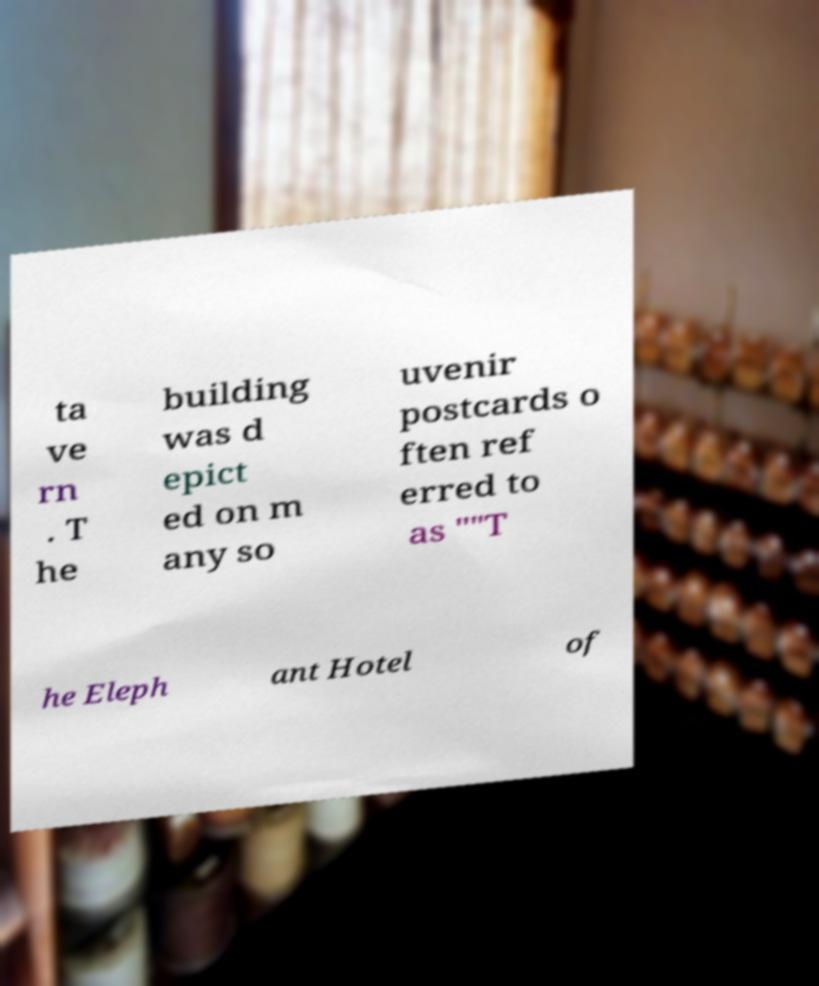Could you assist in decoding the text presented in this image and type it out clearly? ta ve rn . T he building was d epict ed on m any so uvenir postcards o ften ref erred to as ""T he Eleph ant Hotel of 